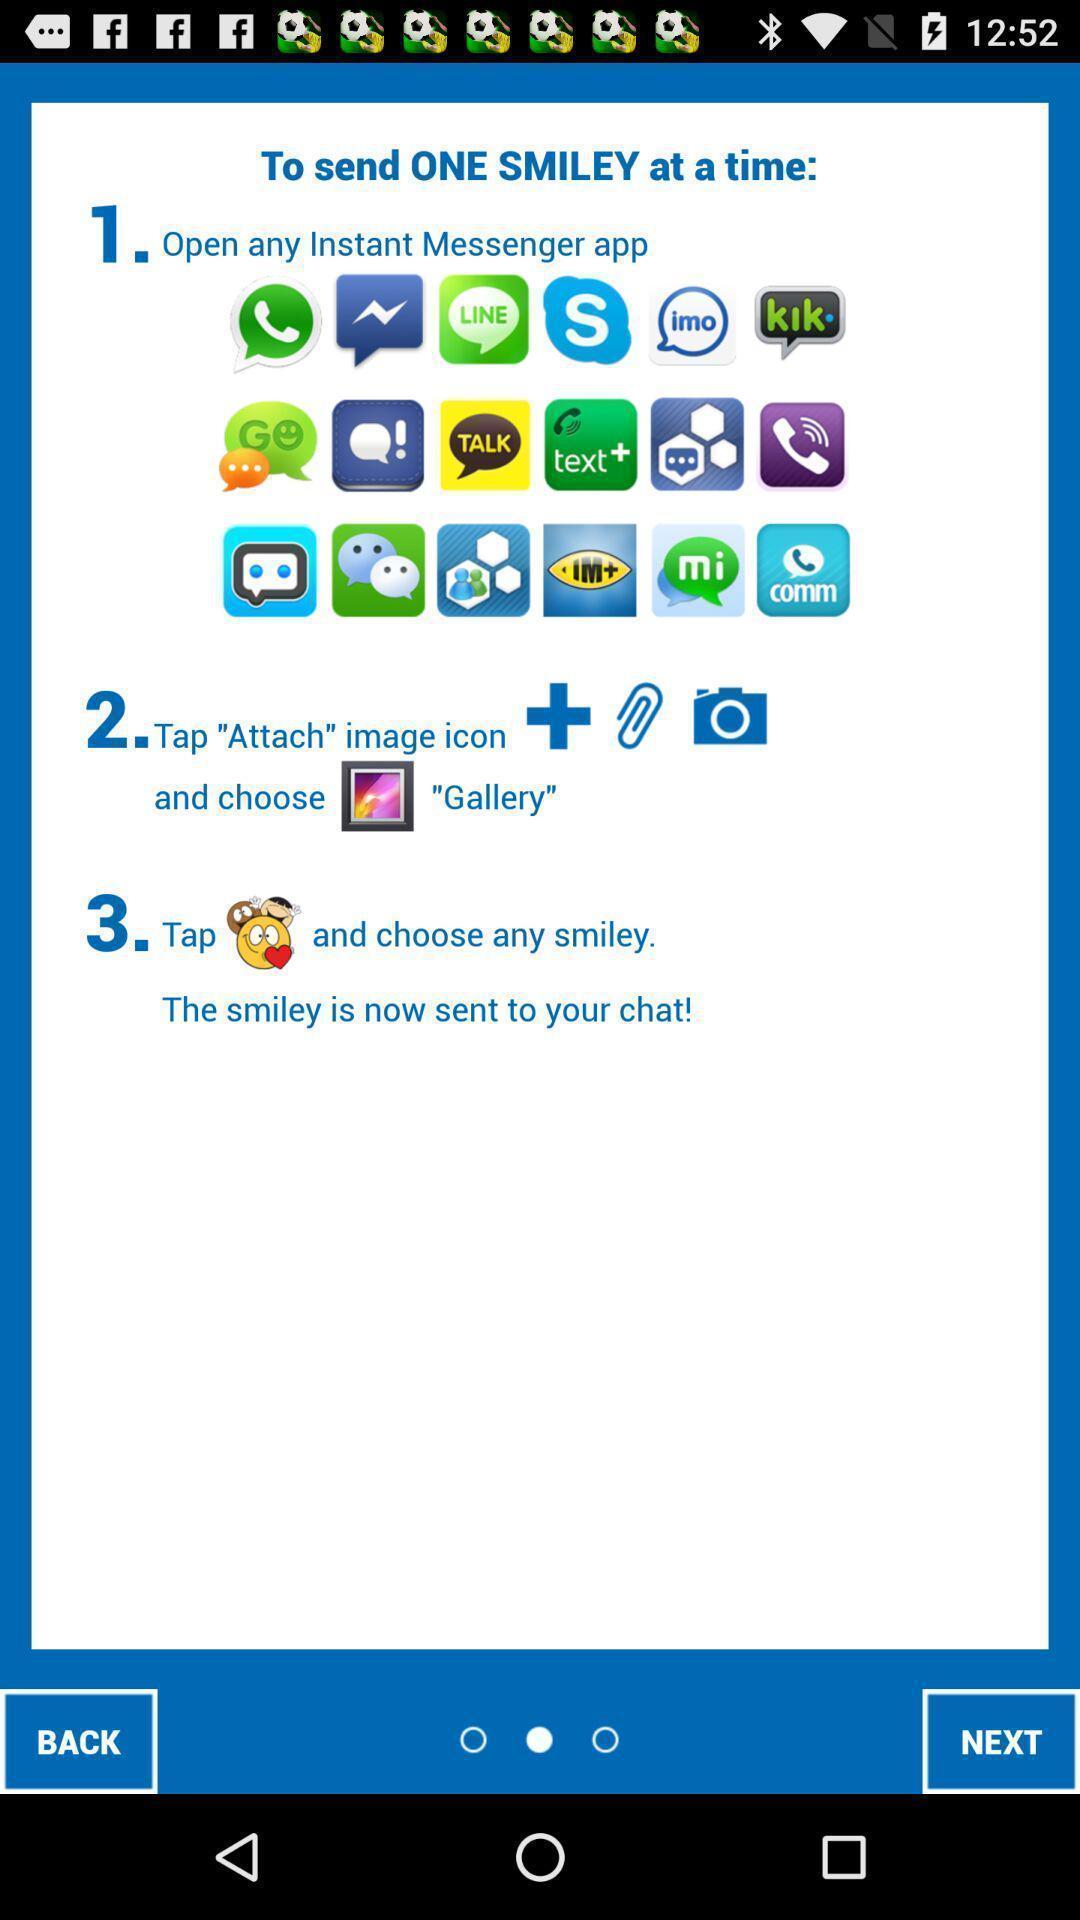What details can you identify in this image? Screen shows instructions to send one smiley at a time. 